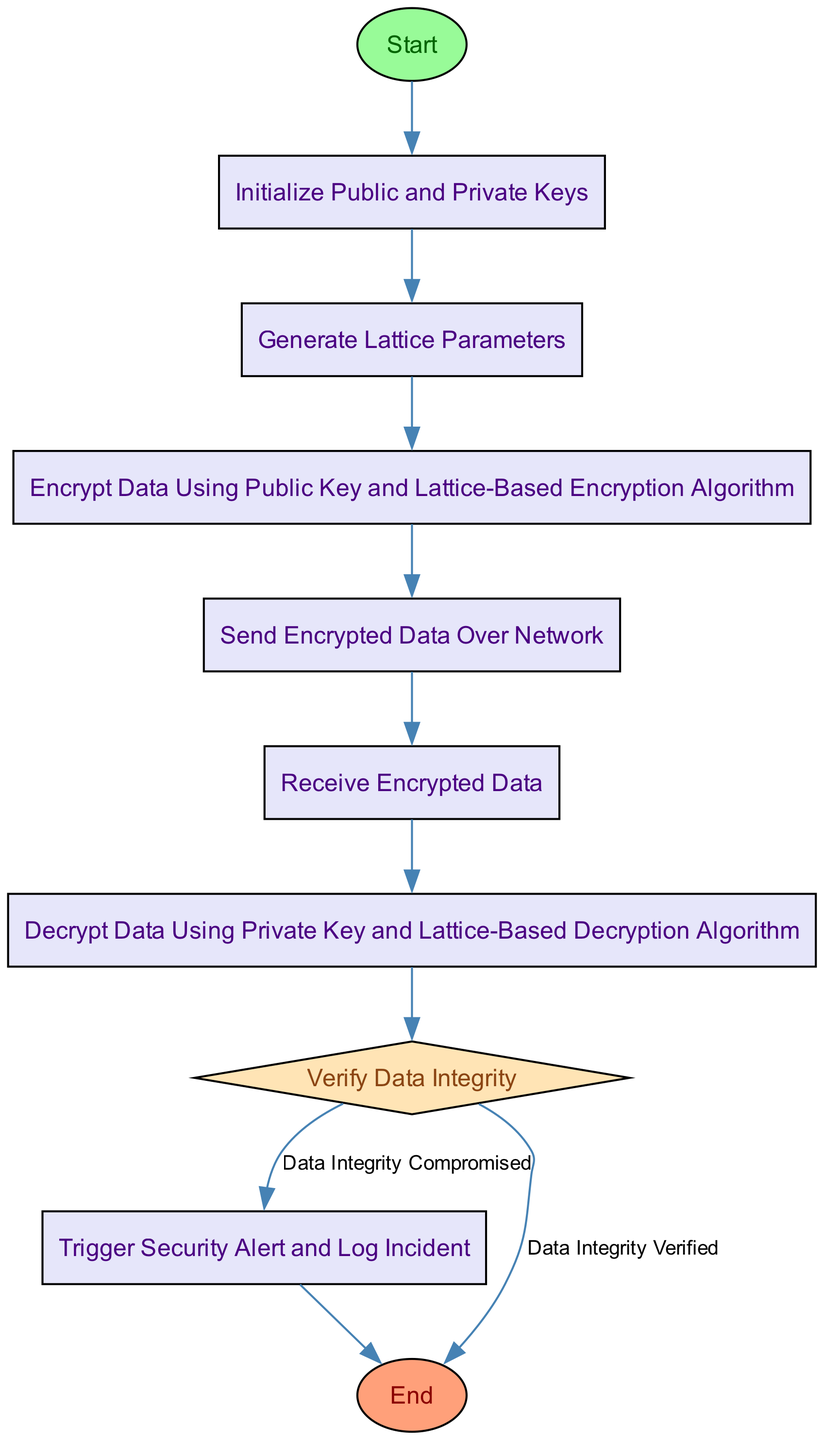What is the first step in the diagram? The diagram starts with the "Start" node, which is the initial point in the workflow. From there, it transitions to the next step labeled "Initialize Public and Private Keys."
Answer: Start How many decision nodes are in the diagram? The diagram contains one decision node, which is "Verify Data Integrity." This node evaluates the integrity of the data after decryption.
Answer: 1 What is the last process node before the end? The last process node before reaching the end is "Trigger Security Alert and Log Incident." This occurs only if the data integrity is compromised.
Answer: Trigger Security Alert and Log Incident What follows after "Receive Encrypted Data"? After "Receive Encrypted Data," the next step in the flow is "Decrypt Data Using Private Key and Lattice-Based Decryption Algorithm." This signifies the decryption process following the reception of encrypted data.
Answer: Decrypt Data Using Private Key and Lattice-Based Decryption Algorithm What are the two outcomes of the decision node? The two outcomes of the decision node "Verify Data Integrity" are "Data Integrity Verified" and "Data Integrity Compromised." Each outcome directs the flow to a different node based on the verification result.
Answer: Data Integrity Verified and Data Integrity Compromised What is the transition from "Decrypt Data"? The transition from "Decrypt Data" leads to the "Verify Data Integrity" decision node, indicating the next step involves checking whether the decrypted data maintains its integrity.
Answer: Verify Data Integrity What happens if data integrity is compromised? If data integrity is compromised, the flow will move to "Trigger Security Alert and Log Incident," signifying that an alert is raised and the incident is logged.
Answer: Trigger Security Alert and Log Incident 